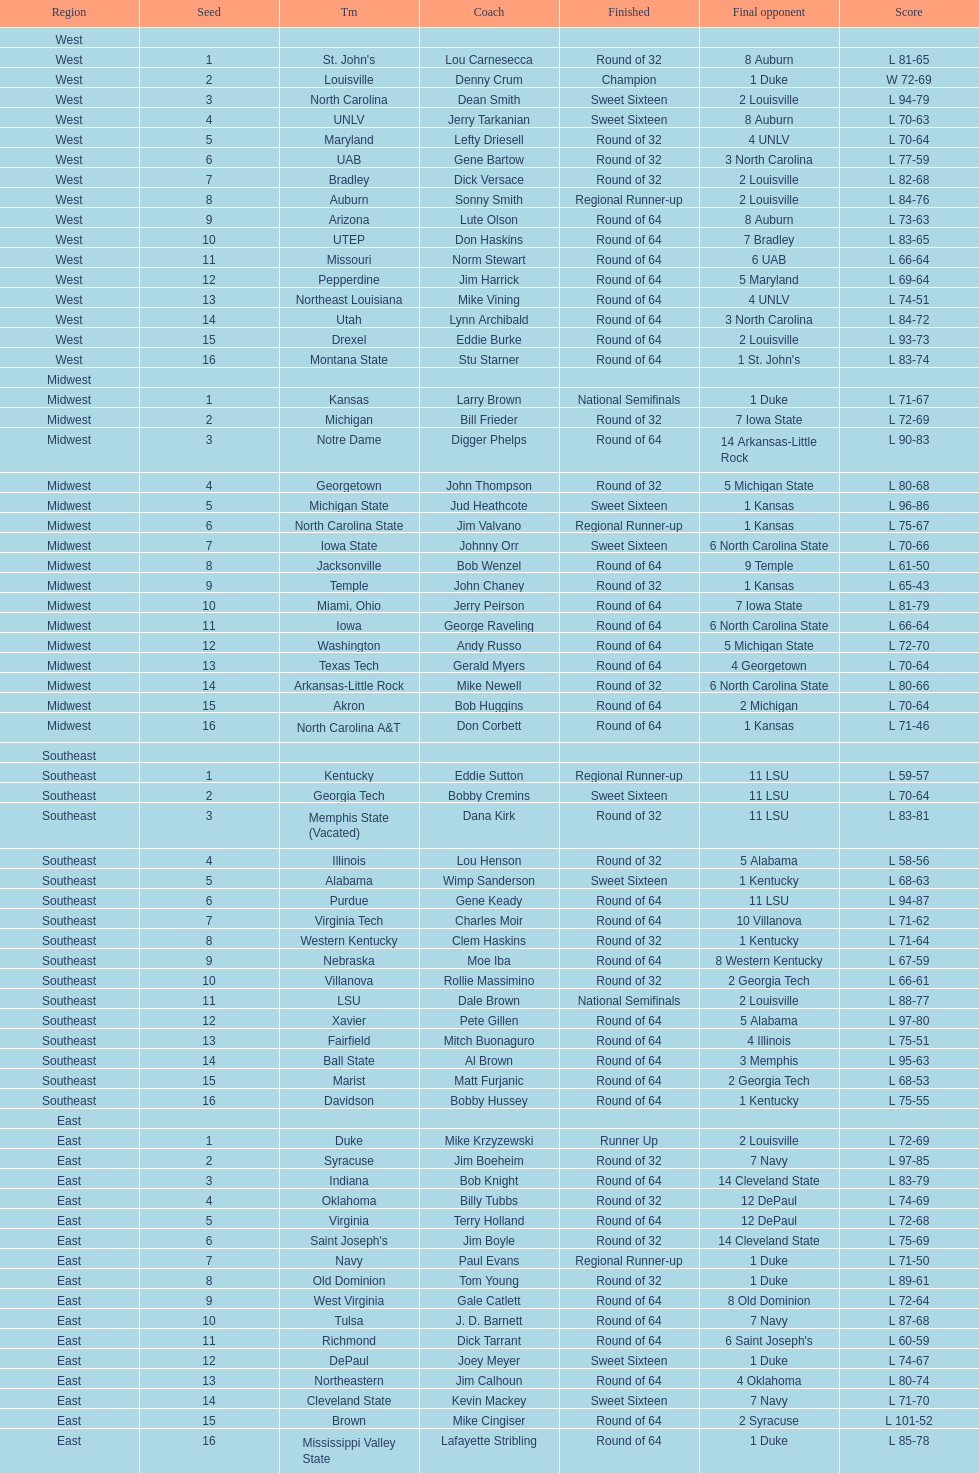In the tournament, did st. john's or north carolina a&t make it further before being eliminated? North Carolina A&T. 